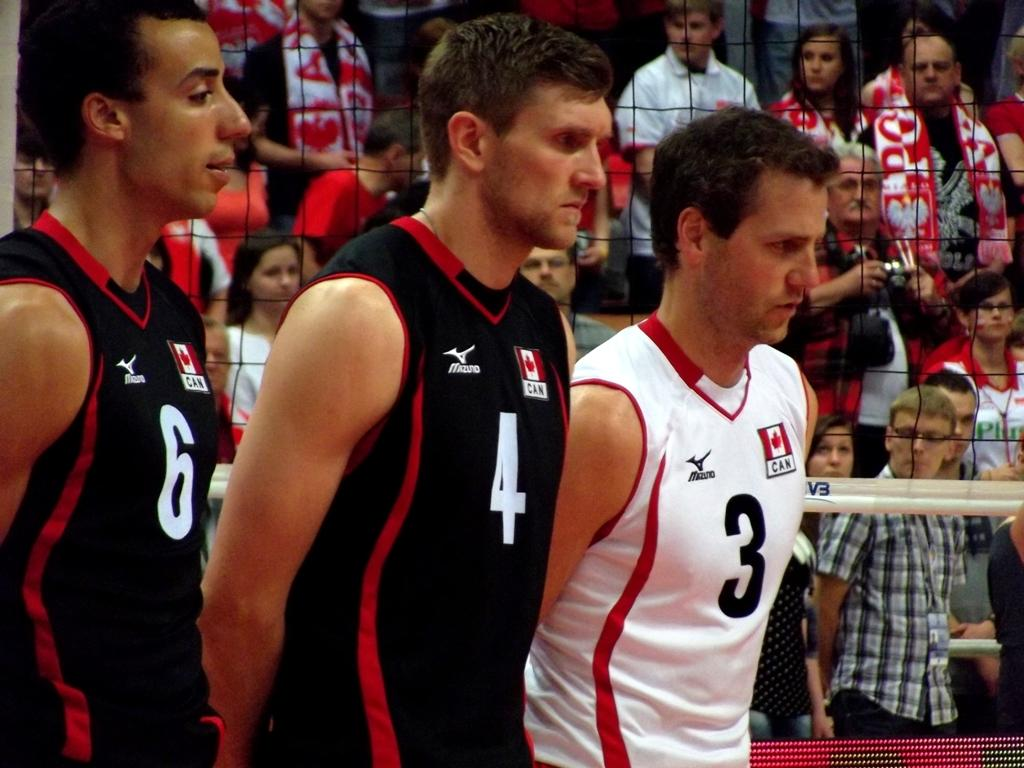How many people are actively participating in the activity in the image? There are three players in the image. What type of clothing are the players wearing? The players are wearing sportswear. What is the main feature of the playing area in the image? There is a net in the image. Are there any spectators in the image? Yes, there are people standing and watching the players. What type of polish is the stranger applying to the birthday cake in the image? There is no stranger, polish, or birthday cake present in the image. 